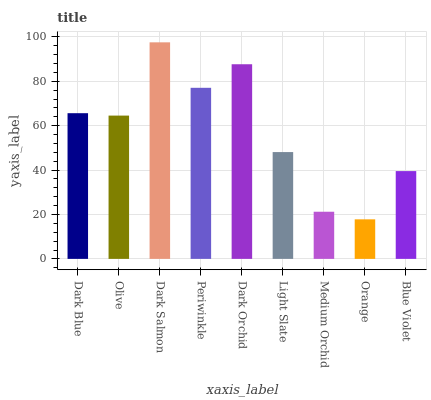Is Olive the minimum?
Answer yes or no. No. Is Olive the maximum?
Answer yes or no. No. Is Dark Blue greater than Olive?
Answer yes or no. Yes. Is Olive less than Dark Blue?
Answer yes or no. Yes. Is Olive greater than Dark Blue?
Answer yes or no. No. Is Dark Blue less than Olive?
Answer yes or no. No. Is Olive the high median?
Answer yes or no. Yes. Is Olive the low median?
Answer yes or no. Yes. Is Light Slate the high median?
Answer yes or no. No. Is Periwinkle the low median?
Answer yes or no. No. 